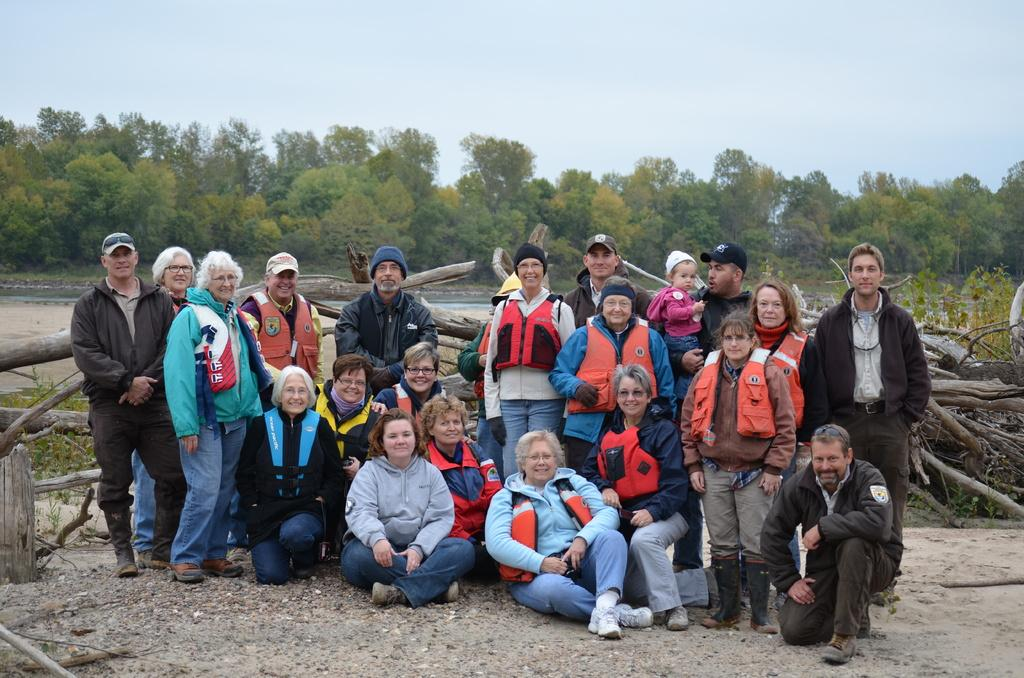How many people are in the image? There is a group of people in the image, but the exact number is not specified. What are the people in the image doing? Some of the people are sitting, while others are standing, and they are laughing. What are the people wearing that might be related to water activities? Many of the people are wearing life jackets. What can be seen in the image besides the people? There are logs visible in the image, as well as green trees in the middle of the image and the sky at the top of the image. How many tramp chickens are visible in the image? There are no tramp chickens present in the image. What type of hand is holding the logs in the image? There is no hand visible in the image holding the logs; they are simply present in the scene. 